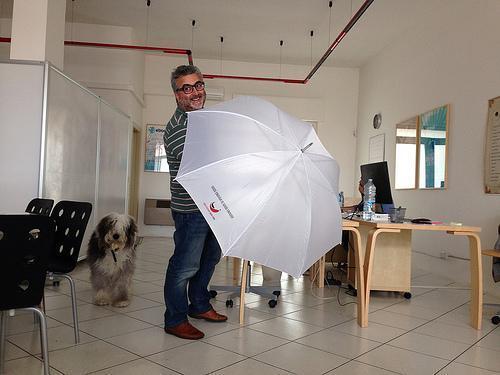How many people are wearing glasses?
Give a very brief answer. 1. 